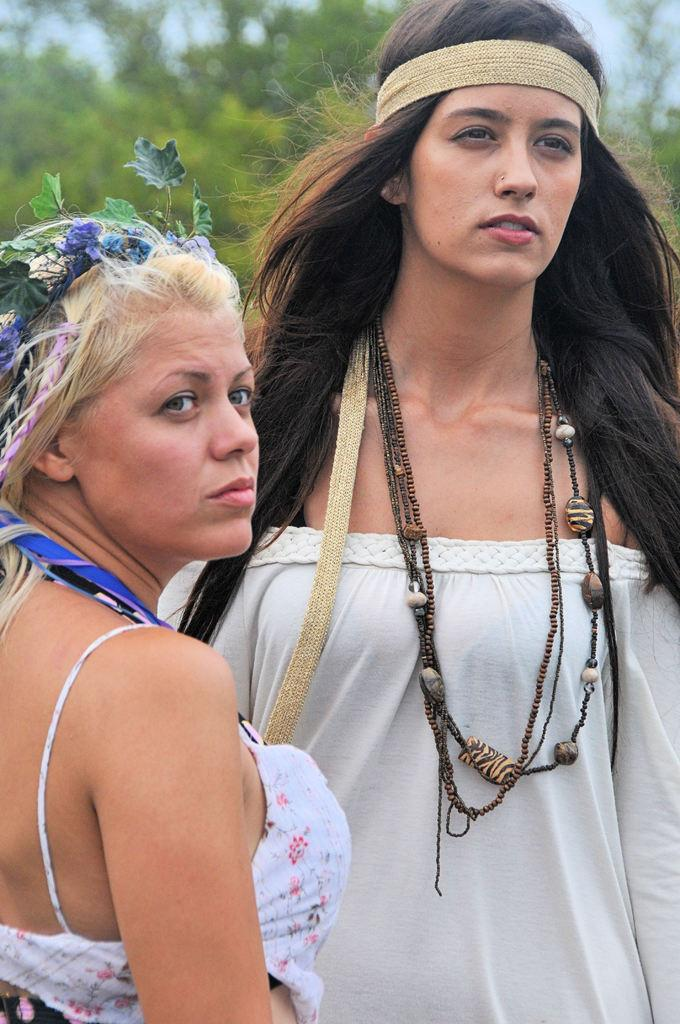How many people are present in the image? There are two persons standing in the image. What can be seen in the background of the image? There are trees and the sky visible in the background of the image. What type of fruit is hanging from the trees in the image? There is no fruit visible in the image; only trees and the sky are present in the background. 